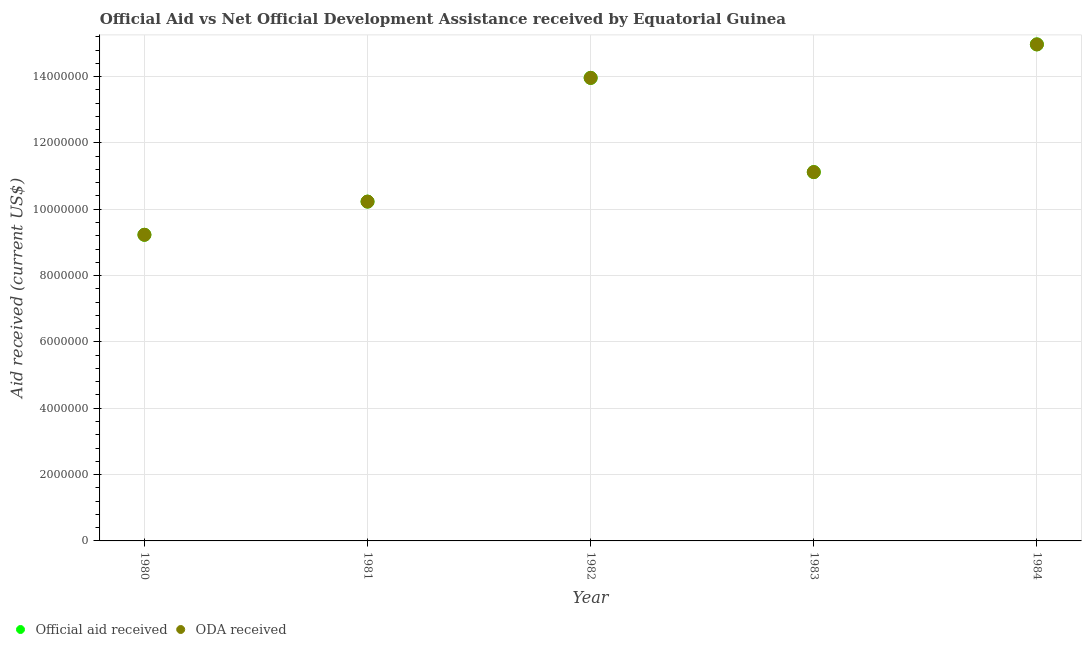What is the oda received in 1980?
Your response must be concise. 9.23e+06. Across all years, what is the maximum oda received?
Make the answer very short. 1.50e+07. Across all years, what is the minimum oda received?
Give a very brief answer. 9.23e+06. In which year was the official aid received maximum?
Make the answer very short. 1984. In which year was the official aid received minimum?
Your response must be concise. 1980. What is the total oda received in the graph?
Offer a terse response. 5.95e+07. What is the difference between the official aid received in 1980 and that in 1981?
Give a very brief answer. -1.00e+06. What is the difference between the official aid received in 1981 and the oda received in 1980?
Provide a succinct answer. 1.00e+06. What is the average official aid received per year?
Your answer should be compact. 1.19e+07. In the year 1982, what is the difference between the official aid received and oda received?
Make the answer very short. 0. What is the ratio of the oda received in 1981 to that in 1983?
Your answer should be compact. 0.92. Is the oda received in 1983 less than that in 1984?
Offer a very short reply. Yes. Is the difference between the oda received in 1981 and 1982 greater than the difference between the official aid received in 1981 and 1982?
Give a very brief answer. No. What is the difference between the highest and the second highest official aid received?
Provide a short and direct response. 1.01e+06. What is the difference between the highest and the lowest official aid received?
Ensure brevity in your answer.  5.74e+06. In how many years, is the oda received greater than the average oda received taken over all years?
Give a very brief answer. 2. Does the official aid received monotonically increase over the years?
Offer a very short reply. No. Is the oda received strictly greater than the official aid received over the years?
Keep it short and to the point. No. How many dotlines are there?
Your response must be concise. 2. Does the graph contain any zero values?
Your answer should be very brief. No. Does the graph contain grids?
Provide a short and direct response. Yes. How are the legend labels stacked?
Provide a succinct answer. Horizontal. What is the title of the graph?
Make the answer very short. Official Aid vs Net Official Development Assistance received by Equatorial Guinea . Does "Excluding technical cooperation" appear as one of the legend labels in the graph?
Offer a very short reply. No. What is the label or title of the Y-axis?
Offer a terse response. Aid received (current US$). What is the Aid received (current US$) in Official aid received in 1980?
Make the answer very short. 9.23e+06. What is the Aid received (current US$) in ODA received in 1980?
Give a very brief answer. 9.23e+06. What is the Aid received (current US$) in Official aid received in 1981?
Your response must be concise. 1.02e+07. What is the Aid received (current US$) in ODA received in 1981?
Your answer should be compact. 1.02e+07. What is the Aid received (current US$) in Official aid received in 1982?
Your response must be concise. 1.40e+07. What is the Aid received (current US$) of ODA received in 1982?
Your response must be concise. 1.40e+07. What is the Aid received (current US$) of Official aid received in 1983?
Offer a very short reply. 1.11e+07. What is the Aid received (current US$) of ODA received in 1983?
Your response must be concise. 1.11e+07. What is the Aid received (current US$) in Official aid received in 1984?
Make the answer very short. 1.50e+07. What is the Aid received (current US$) in ODA received in 1984?
Ensure brevity in your answer.  1.50e+07. Across all years, what is the maximum Aid received (current US$) in Official aid received?
Give a very brief answer. 1.50e+07. Across all years, what is the maximum Aid received (current US$) of ODA received?
Ensure brevity in your answer.  1.50e+07. Across all years, what is the minimum Aid received (current US$) in Official aid received?
Keep it short and to the point. 9.23e+06. Across all years, what is the minimum Aid received (current US$) of ODA received?
Ensure brevity in your answer.  9.23e+06. What is the total Aid received (current US$) of Official aid received in the graph?
Make the answer very short. 5.95e+07. What is the total Aid received (current US$) of ODA received in the graph?
Your answer should be very brief. 5.95e+07. What is the difference between the Aid received (current US$) of ODA received in 1980 and that in 1981?
Provide a short and direct response. -1.00e+06. What is the difference between the Aid received (current US$) in Official aid received in 1980 and that in 1982?
Ensure brevity in your answer.  -4.73e+06. What is the difference between the Aid received (current US$) of ODA received in 1980 and that in 1982?
Provide a short and direct response. -4.73e+06. What is the difference between the Aid received (current US$) in Official aid received in 1980 and that in 1983?
Provide a succinct answer. -1.89e+06. What is the difference between the Aid received (current US$) of ODA received in 1980 and that in 1983?
Offer a terse response. -1.89e+06. What is the difference between the Aid received (current US$) in Official aid received in 1980 and that in 1984?
Your answer should be compact. -5.74e+06. What is the difference between the Aid received (current US$) in ODA received in 1980 and that in 1984?
Provide a short and direct response. -5.74e+06. What is the difference between the Aid received (current US$) in Official aid received in 1981 and that in 1982?
Ensure brevity in your answer.  -3.73e+06. What is the difference between the Aid received (current US$) of ODA received in 1981 and that in 1982?
Ensure brevity in your answer.  -3.73e+06. What is the difference between the Aid received (current US$) in Official aid received in 1981 and that in 1983?
Keep it short and to the point. -8.90e+05. What is the difference between the Aid received (current US$) in ODA received in 1981 and that in 1983?
Provide a succinct answer. -8.90e+05. What is the difference between the Aid received (current US$) of Official aid received in 1981 and that in 1984?
Keep it short and to the point. -4.74e+06. What is the difference between the Aid received (current US$) in ODA received in 1981 and that in 1984?
Offer a very short reply. -4.74e+06. What is the difference between the Aid received (current US$) in Official aid received in 1982 and that in 1983?
Your answer should be compact. 2.84e+06. What is the difference between the Aid received (current US$) in ODA received in 1982 and that in 1983?
Give a very brief answer. 2.84e+06. What is the difference between the Aid received (current US$) of Official aid received in 1982 and that in 1984?
Your answer should be very brief. -1.01e+06. What is the difference between the Aid received (current US$) in ODA received in 1982 and that in 1984?
Ensure brevity in your answer.  -1.01e+06. What is the difference between the Aid received (current US$) in Official aid received in 1983 and that in 1984?
Make the answer very short. -3.85e+06. What is the difference between the Aid received (current US$) in ODA received in 1983 and that in 1984?
Ensure brevity in your answer.  -3.85e+06. What is the difference between the Aid received (current US$) of Official aid received in 1980 and the Aid received (current US$) of ODA received in 1981?
Provide a succinct answer. -1.00e+06. What is the difference between the Aid received (current US$) in Official aid received in 1980 and the Aid received (current US$) in ODA received in 1982?
Provide a short and direct response. -4.73e+06. What is the difference between the Aid received (current US$) in Official aid received in 1980 and the Aid received (current US$) in ODA received in 1983?
Offer a very short reply. -1.89e+06. What is the difference between the Aid received (current US$) of Official aid received in 1980 and the Aid received (current US$) of ODA received in 1984?
Keep it short and to the point. -5.74e+06. What is the difference between the Aid received (current US$) in Official aid received in 1981 and the Aid received (current US$) in ODA received in 1982?
Provide a succinct answer. -3.73e+06. What is the difference between the Aid received (current US$) of Official aid received in 1981 and the Aid received (current US$) of ODA received in 1983?
Ensure brevity in your answer.  -8.90e+05. What is the difference between the Aid received (current US$) in Official aid received in 1981 and the Aid received (current US$) in ODA received in 1984?
Your answer should be very brief. -4.74e+06. What is the difference between the Aid received (current US$) of Official aid received in 1982 and the Aid received (current US$) of ODA received in 1983?
Your answer should be very brief. 2.84e+06. What is the difference between the Aid received (current US$) of Official aid received in 1982 and the Aid received (current US$) of ODA received in 1984?
Ensure brevity in your answer.  -1.01e+06. What is the difference between the Aid received (current US$) of Official aid received in 1983 and the Aid received (current US$) of ODA received in 1984?
Ensure brevity in your answer.  -3.85e+06. What is the average Aid received (current US$) of Official aid received per year?
Give a very brief answer. 1.19e+07. What is the average Aid received (current US$) in ODA received per year?
Provide a short and direct response. 1.19e+07. In the year 1981, what is the difference between the Aid received (current US$) of Official aid received and Aid received (current US$) of ODA received?
Offer a terse response. 0. In the year 1983, what is the difference between the Aid received (current US$) of Official aid received and Aid received (current US$) of ODA received?
Give a very brief answer. 0. What is the ratio of the Aid received (current US$) in Official aid received in 1980 to that in 1981?
Offer a very short reply. 0.9. What is the ratio of the Aid received (current US$) of ODA received in 1980 to that in 1981?
Make the answer very short. 0.9. What is the ratio of the Aid received (current US$) of Official aid received in 1980 to that in 1982?
Your answer should be compact. 0.66. What is the ratio of the Aid received (current US$) in ODA received in 1980 to that in 1982?
Your answer should be compact. 0.66. What is the ratio of the Aid received (current US$) of Official aid received in 1980 to that in 1983?
Make the answer very short. 0.83. What is the ratio of the Aid received (current US$) in ODA received in 1980 to that in 1983?
Make the answer very short. 0.83. What is the ratio of the Aid received (current US$) in Official aid received in 1980 to that in 1984?
Give a very brief answer. 0.62. What is the ratio of the Aid received (current US$) in ODA received in 1980 to that in 1984?
Your answer should be compact. 0.62. What is the ratio of the Aid received (current US$) in Official aid received in 1981 to that in 1982?
Provide a succinct answer. 0.73. What is the ratio of the Aid received (current US$) in ODA received in 1981 to that in 1982?
Ensure brevity in your answer.  0.73. What is the ratio of the Aid received (current US$) in Official aid received in 1981 to that in 1984?
Provide a short and direct response. 0.68. What is the ratio of the Aid received (current US$) in ODA received in 1981 to that in 1984?
Offer a terse response. 0.68. What is the ratio of the Aid received (current US$) in Official aid received in 1982 to that in 1983?
Provide a succinct answer. 1.26. What is the ratio of the Aid received (current US$) in ODA received in 1982 to that in 1983?
Ensure brevity in your answer.  1.26. What is the ratio of the Aid received (current US$) in Official aid received in 1982 to that in 1984?
Ensure brevity in your answer.  0.93. What is the ratio of the Aid received (current US$) of ODA received in 1982 to that in 1984?
Make the answer very short. 0.93. What is the ratio of the Aid received (current US$) in Official aid received in 1983 to that in 1984?
Your answer should be compact. 0.74. What is the ratio of the Aid received (current US$) in ODA received in 1983 to that in 1984?
Your answer should be very brief. 0.74. What is the difference between the highest and the second highest Aid received (current US$) in Official aid received?
Give a very brief answer. 1.01e+06. What is the difference between the highest and the second highest Aid received (current US$) of ODA received?
Your answer should be compact. 1.01e+06. What is the difference between the highest and the lowest Aid received (current US$) in Official aid received?
Offer a very short reply. 5.74e+06. What is the difference between the highest and the lowest Aid received (current US$) in ODA received?
Keep it short and to the point. 5.74e+06. 